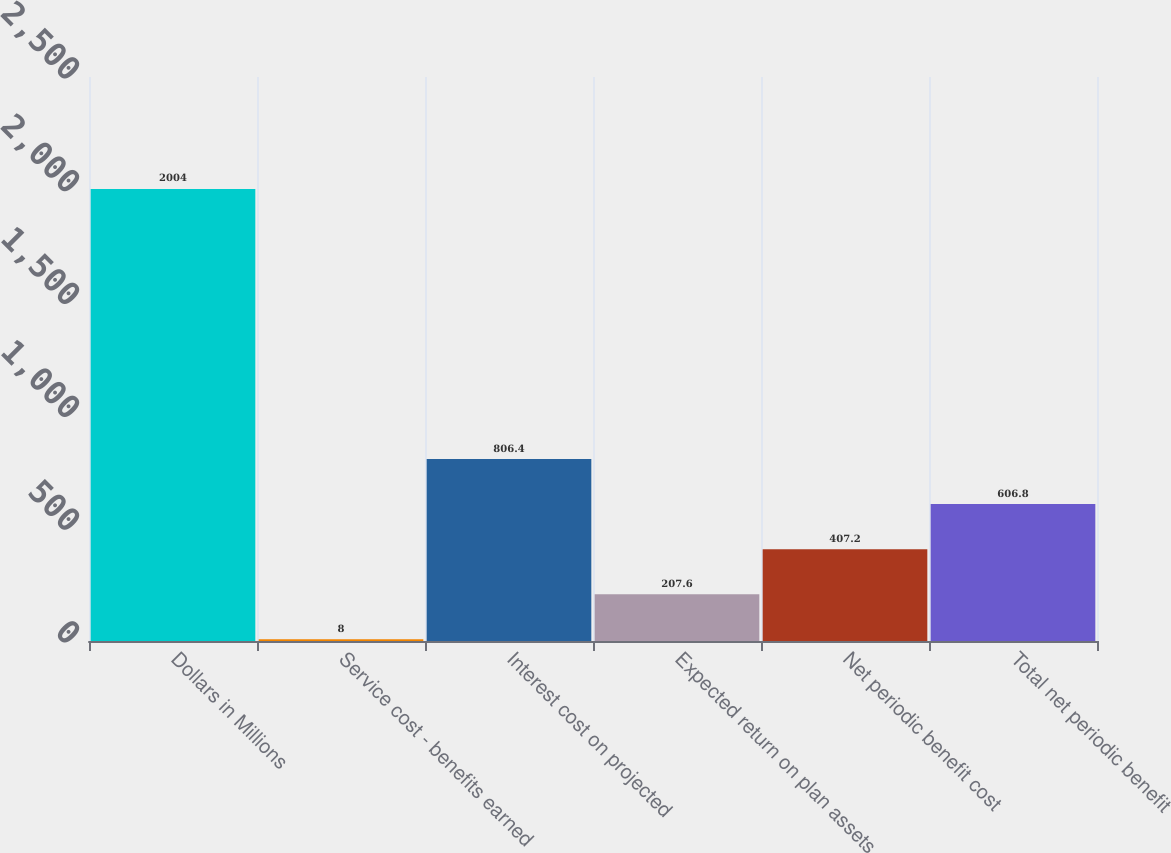Convert chart to OTSL. <chart><loc_0><loc_0><loc_500><loc_500><bar_chart><fcel>Dollars in Millions<fcel>Service cost - benefits earned<fcel>Interest cost on projected<fcel>Expected return on plan assets<fcel>Net periodic benefit cost<fcel>Total net periodic benefit<nl><fcel>2004<fcel>8<fcel>806.4<fcel>207.6<fcel>407.2<fcel>606.8<nl></chart> 